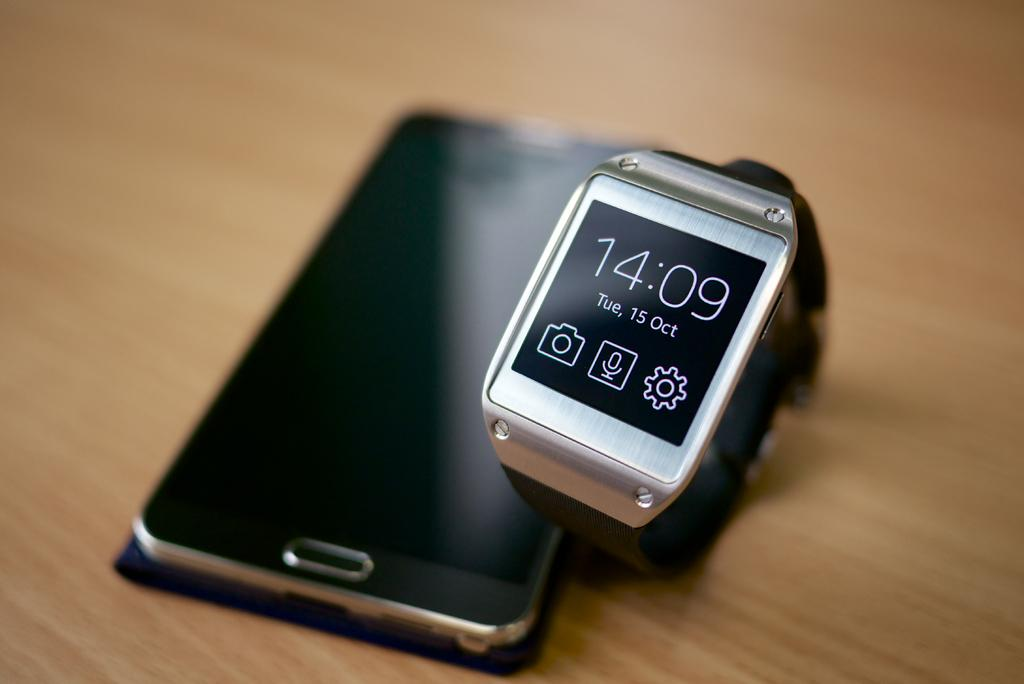<image>
Provide a brief description of the given image. A smart watch shows the time to be 14:09 on Tue, 15 Oct. 